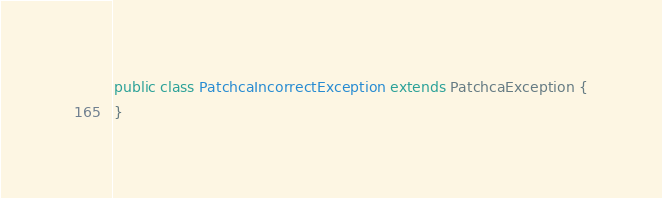<code> <loc_0><loc_0><loc_500><loc_500><_Java_>public class PatchcaIncorrectException extends PatchcaException {
}
</code> 